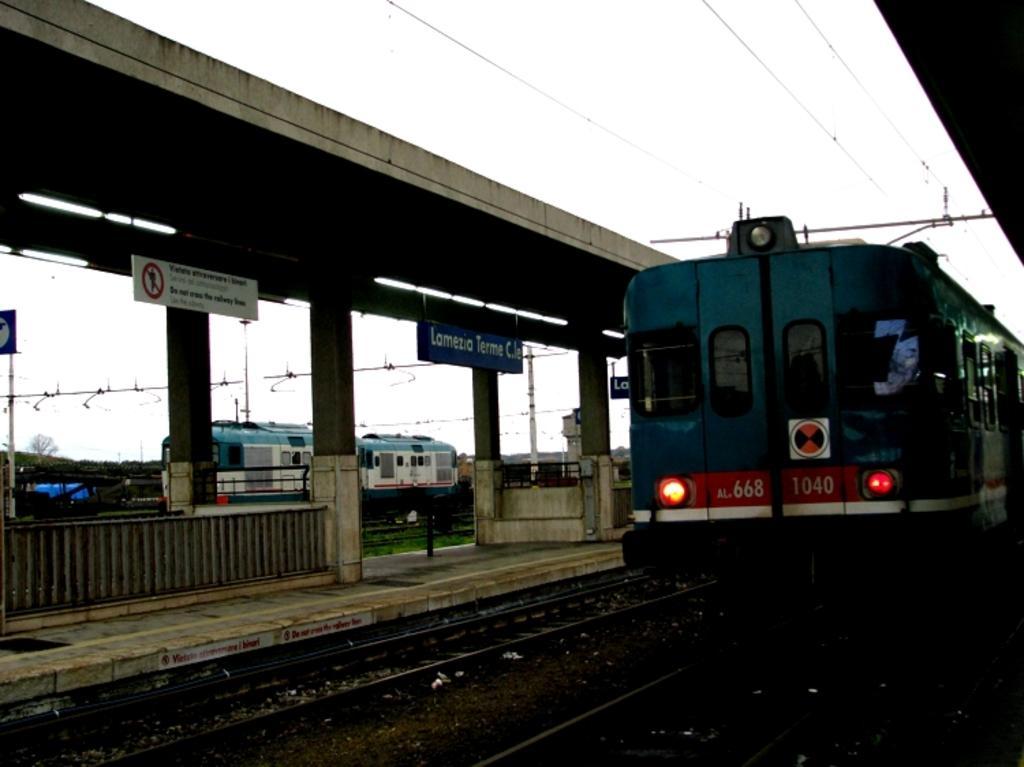Can you describe this image briefly? On the right side, there is a train on a railway track. Above this train, there are electric lines and a roof. On the left side, there is a railway track. Beside this railway track, there is a platform having hoardings, a roof and pillars. In the background, there is another train, poles, trees and there are clouds in the sky. 